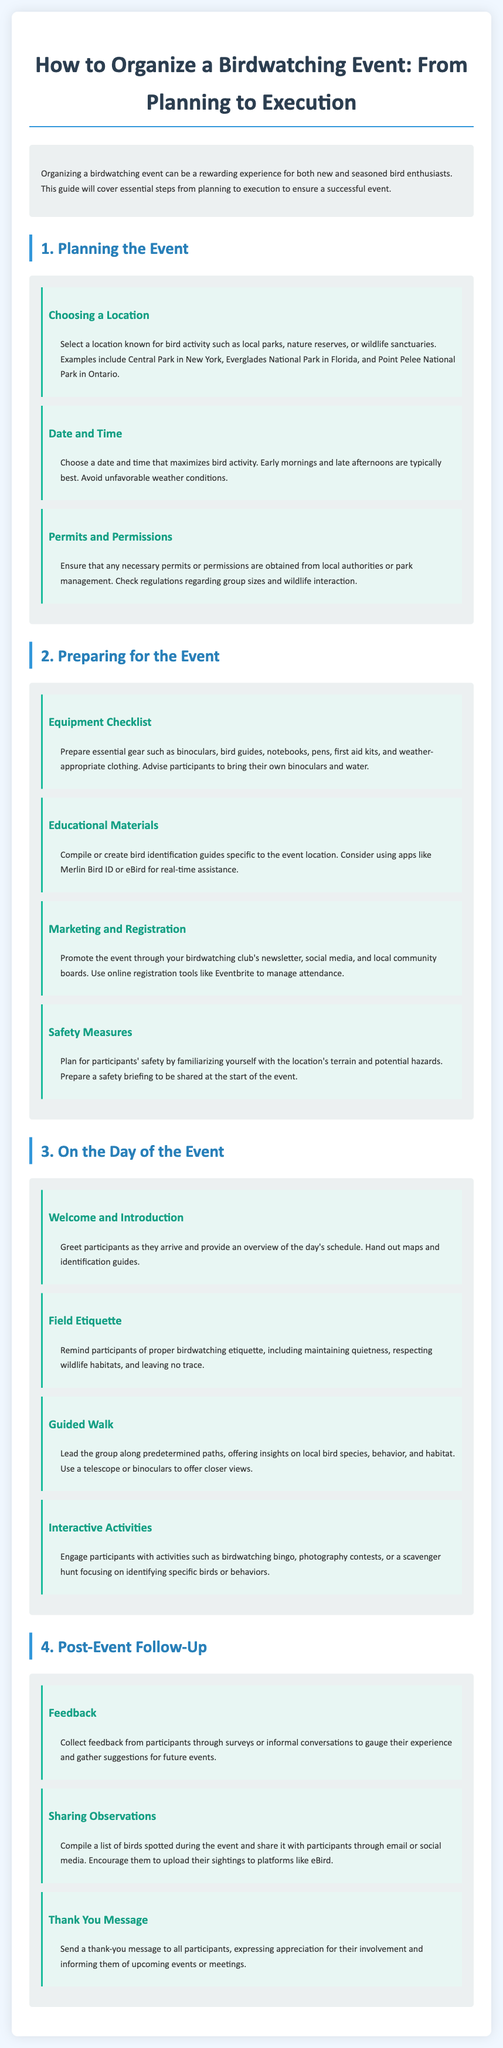What is the first step of organizing a birdwatching event? The first step involves planning the event, including choosing a location and date.
Answer: Planning the Event What is a recommended time for birdwatching activities? Early mornings and late afternoons are typically best for birdwatching due to higher bird activity.
Answer: Early mornings and late afternoons Which document is suggested for compiling bird sightings post-event? Participants are encouraged to upload their sightings to eBird.
Answer: eBird What should be included in the equipment checklist? Essential gear includes binoculars, bird guides, notebooks, and first aid kits.
Answer: Binoculars, bird guides, notebooks, first aid kits What is a suggested marketing tool for the event? Promoting the event can be done through local community boards and online platforms like Eventbrite.
Answer: Eventbrite What interactive activity can be conducted during the event? Engaging participants with birdwatching bingo is one of the suggested activities.
Answer: Birdwatching bingo What is the purpose of collecting feedback after the event? The feedback helps gauge participant experience and gather suggestions for future events.
Answer: Gauge experience and suggestions What should be included in the post-event thank-you message? Informing participants of upcoming events or meetings is part of the thank-you message.
Answer: Upcoming events or meetings 